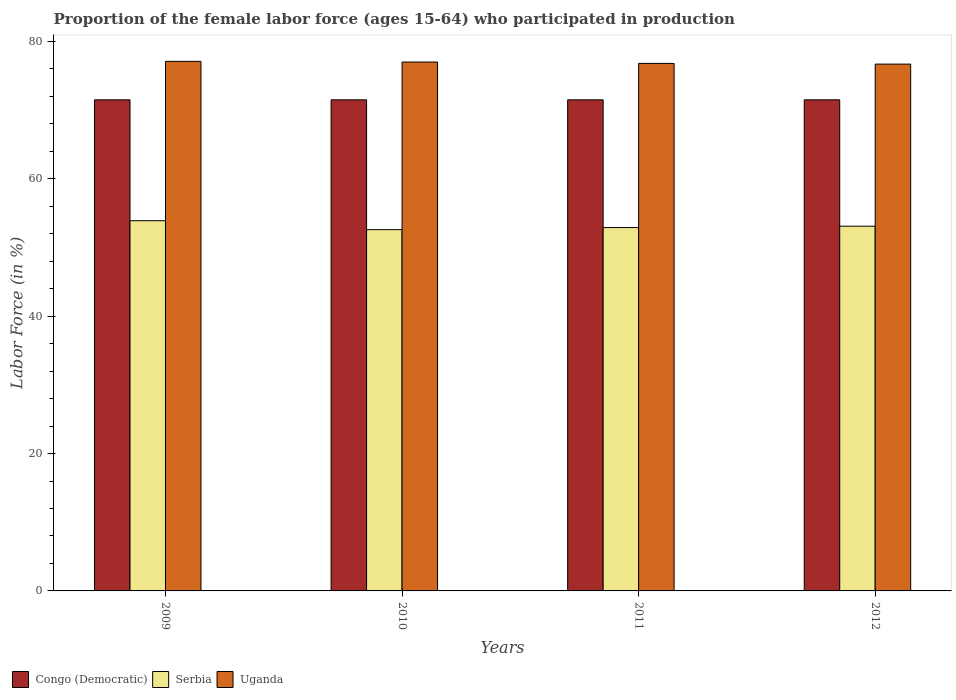How many groups of bars are there?
Provide a succinct answer. 4. Are the number of bars per tick equal to the number of legend labels?
Ensure brevity in your answer.  Yes. How many bars are there on the 2nd tick from the right?
Ensure brevity in your answer.  3. What is the label of the 2nd group of bars from the left?
Ensure brevity in your answer.  2010. Across all years, what is the maximum proportion of the female labor force who participated in production in Serbia?
Provide a short and direct response. 53.9. Across all years, what is the minimum proportion of the female labor force who participated in production in Congo (Democratic)?
Offer a terse response. 71.5. In which year was the proportion of the female labor force who participated in production in Serbia maximum?
Ensure brevity in your answer.  2009. What is the total proportion of the female labor force who participated in production in Uganda in the graph?
Provide a succinct answer. 307.6. What is the difference between the proportion of the female labor force who participated in production in Uganda in 2009 and that in 2011?
Keep it short and to the point. 0.3. What is the difference between the proportion of the female labor force who participated in production in Serbia in 2011 and the proportion of the female labor force who participated in production in Uganda in 2009?
Your answer should be very brief. -24.2. What is the average proportion of the female labor force who participated in production in Congo (Democratic) per year?
Provide a short and direct response. 71.5. In the year 2009, what is the difference between the proportion of the female labor force who participated in production in Congo (Democratic) and proportion of the female labor force who participated in production in Serbia?
Make the answer very short. 17.6. In how many years, is the proportion of the female labor force who participated in production in Congo (Democratic) greater than 68 %?
Offer a very short reply. 4. What is the ratio of the proportion of the female labor force who participated in production in Serbia in 2009 to that in 2011?
Make the answer very short. 1.02. Is the proportion of the female labor force who participated in production in Serbia in 2011 less than that in 2012?
Your response must be concise. Yes. Is the difference between the proportion of the female labor force who participated in production in Congo (Democratic) in 2009 and 2010 greater than the difference between the proportion of the female labor force who participated in production in Serbia in 2009 and 2010?
Provide a short and direct response. No. What is the difference between the highest and the second highest proportion of the female labor force who participated in production in Uganda?
Offer a terse response. 0.1. What is the difference between the highest and the lowest proportion of the female labor force who participated in production in Congo (Democratic)?
Your answer should be compact. 0. Is the sum of the proportion of the female labor force who participated in production in Congo (Democratic) in 2009 and 2010 greater than the maximum proportion of the female labor force who participated in production in Uganda across all years?
Offer a very short reply. Yes. What does the 2nd bar from the left in 2011 represents?
Ensure brevity in your answer.  Serbia. What does the 3rd bar from the right in 2012 represents?
Make the answer very short. Congo (Democratic). Is it the case that in every year, the sum of the proportion of the female labor force who participated in production in Congo (Democratic) and proportion of the female labor force who participated in production in Uganda is greater than the proportion of the female labor force who participated in production in Serbia?
Your response must be concise. Yes. Are all the bars in the graph horizontal?
Keep it short and to the point. No. What is the difference between two consecutive major ticks on the Y-axis?
Your response must be concise. 20. Are the values on the major ticks of Y-axis written in scientific E-notation?
Give a very brief answer. No. Does the graph contain grids?
Ensure brevity in your answer.  No. How are the legend labels stacked?
Give a very brief answer. Horizontal. What is the title of the graph?
Give a very brief answer. Proportion of the female labor force (ages 15-64) who participated in production. What is the label or title of the X-axis?
Ensure brevity in your answer.  Years. What is the label or title of the Y-axis?
Keep it short and to the point. Labor Force (in %). What is the Labor Force (in %) of Congo (Democratic) in 2009?
Your answer should be compact. 71.5. What is the Labor Force (in %) in Serbia in 2009?
Ensure brevity in your answer.  53.9. What is the Labor Force (in %) in Uganda in 2009?
Offer a very short reply. 77.1. What is the Labor Force (in %) of Congo (Democratic) in 2010?
Make the answer very short. 71.5. What is the Labor Force (in %) of Serbia in 2010?
Your answer should be very brief. 52.6. What is the Labor Force (in %) of Uganda in 2010?
Your response must be concise. 77. What is the Labor Force (in %) in Congo (Democratic) in 2011?
Give a very brief answer. 71.5. What is the Labor Force (in %) in Serbia in 2011?
Keep it short and to the point. 52.9. What is the Labor Force (in %) of Uganda in 2011?
Your response must be concise. 76.8. What is the Labor Force (in %) in Congo (Democratic) in 2012?
Your response must be concise. 71.5. What is the Labor Force (in %) of Serbia in 2012?
Make the answer very short. 53.1. What is the Labor Force (in %) of Uganda in 2012?
Your answer should be very brief. 76.7. Across all years, what is the maximum Labor Force (in %) of Congo (Democratic)?
Give a very brief answer. 71.5. Across all years, what is the maximum Labor Force (in %) in Serbia?
Keep it short and to the point. 53.9. Across all years, what is the maximum Labor Force (in %) in Uganda?
Your answer should be compact. 77.1. Across all years, what is the minimum Labor Force (in %) in Congo (Democratic)?
Your answer should be very brief. 71.5. Across all years, what is the minimum Labor Force (in %) of Serbia?
Make the answer very short. 52.6. Across all years, what is the minimum Labor Force (in %) of Uganda?
Provide a succinct answer. 76.7. What is the total Labor Force (in %) in Congo (Democratic) in the graph?
Make the answer very short. 286. What is the total Labor Force (in %) in Serbia in the graph?
Provide a short and direct response. 212.5. What is the total Labor Force (in %) in Uganda in the graph?
Give a very brief answer. 307.6. What is the difference between the Labor Force (in %) of Serbia in 2009 and that in 2010?
Offer a terse response. 1.3. What is the difference between the Labor Force (in %) of Serbia in 2009 and that in 2011?
Provide a short and direct response. 1. What is the difference between the Labor Force (in %) in Uganda in 2009 and that in 2011?
Ensure brevity in your answer.  0.3. What is the difference between the Labor Force (in %) of Serbia in 2009 and that in 2012?
Offer a very short reply. 0.8. What is the difference between the Labor Force (in %) in Congo (Democratic) in 2010 and that in 2012?
Your response must be concise. 0. What is the difference between the Labor Force (in %) of Serbia in 2010 and that in 2012?
Your response must be concise. -0.5. What is the difference between the Labor Force (in %) in Uganda in 2010 and that in 2012?
Offer a terse response. 0.3. What is the difference between the Labor Force (in %) of Serbia in 2011 and that in 2012?
Ensure brevity in your answer.  -0.2. What is the difference between the Labor Force (in %) of Uganda in 2011 and that in 2012?
Give a very brief answer. 0.1. What is the difference between the Labor Force (in %) in Congo (Democratic) in 2009 and the Labor Force (in %) in Serbia in 2010?
Offer a very short reply. 18.9. What is the difference between the Labor Force (in %) in Congo (Democratic) in 2009 and the Labor Force (in %) in Uganda in 2010?
Offer a terse response. -5.5. What is the difference between the Labor Force (in %) of Serbia in 2009 and the Labor Force (in %) of Uganda in 2010?
Your answer should be compact. -23.1. What is the difference between the Labor Force (in %) in Congo (Democratic) in 2009 and the Labor Force (in %) in Serbia in 2011?
Ensure brevity in your answer.  18.6. What is the difference between the Labor Force (in %) of Congo (Democratic) in 2009 and the Labor Force (in %) of Uganda in 2011?
Your answer should be compact. -5.3. What is the difference between the Labor Force (in %) in Serbia in 2009 and the Labor Force (in %) in Uganda in 2011?
Provide a short and direct response. -22.9. What is the difference between the Labor Force (in %) in Serbia in 2009 and the Labor Force (in %) in Uganda in 2012?
Your answer should be compact. -22.8. What is the difference between the Labor Force (in %) in Congo (Democratic) in 2010 and the Labor Force (in %) in Serbia in 2011?
Make the answer very short. 18.6. What is the difference between the Labor Force (in %) of Serbia in 2010 and the Labor Force (in %) of Uganda in 2011?
Provide a short and direct response. -24.2. What is the difference between the Labor Force (in %) of Serbia in 2010 and the Labor Force (in %) of Uganda in 2012?
Provide a succinct answer. -24.1. What is the difference between the Labor Force (in %) of Serbia in 2011 and the Labor Force (in %) of Uganda in 2012?
Offer a very short reply. -23.8. What is the average Labor Force (in %) in Congo (Democratic) per year?
Offer a terse response. 71.5. What is the average Labor Force (in %) in Serbia per year?
Your response must be concise. 53.12. What is the average Labor Force (in %) of Uganda per year?
Your answer should be very brief. 76.9. In the year 2009, what is the difference between the Labor Force (in %) in Congo (Democratic) and Labor Force (in %) in Uganda?
Offer a terse response. -5.6. In the year 2009, what is the difference between the Labor Force (in %) of Serbia and Labor Force (in %) of Uganda?
Provide a succinct answer. -23.2. In the year 2010, what is the difference between the Labor Force (in %) in Congo (Democratic) and Labor Force (in %) in Serbia?
Offer a terse response. 18.9. In the year 2010, what is the difference between the Labor Force (in %) in Serbia and Labor Force (in %) in Uganda?
Provide a short and direct response. -24.4. In the year 2011, what is the difference between the Labor Force (in %) in Congo (Democratic) and Labor Force (in %) in Uganda?
Provide a succinct answer. -5.3. In the year 2011, what is the difference between the Labor Force (in %) in Serbia and Labor Force (in %) in Uganda?
Provide a short and direct response. -23.9. In the year 2012, what is the difference between the Labor Force (in %) of Serbia and Labor Force (in %) of Uganda?
Provide a short and direct response. -23.6. What is the ratio of the Labor Force (in %) of Serbia in 2009 to that in 2010?
Your answer should be very brief. 1.02. What is the ratio of the Labor Force (in %) in Congo (Democratic) in 2009 to that in 2011?
Your answer should be compact. 1. What is the ratio of the Labor Force (in %) of Serbia in 2009 to that in 2011?
Provide a short and direct response. 1.02. What is the ratio of the Labor Force (in %) in Serbia in 2009 to that in 2012?
Keep it short and to the point. 1.02. What is the ratio of the Labor Force (in %) in Uganda in 2009 to that in 2012?
Provide a short and direct response. 1.01. What is the ratio of the Labor Force (in %) of Serbia in 2010 to that in 2011?
Your response must be concise. 0.99. What is the ratio of the Labor Force (in %) in Uganda in 2010 to that in 2011?
Provide a succinct answer. 1. What is the ratio of the Labor Force (in %) in Serbia in 2010 to that in 2012?
Offer a very short reply. 0.99. What is the ratio of the Labor Force (in %) of Congo (Democratic) in 2011 to that in 2012?
Offer a terse response. 1. What is the ratio of the Labor Force (in %) in Serbia in 2011 to that in 2012?
Provide a succinct answer. 1. What is the difference between the highest and the second highest Labor Force (in %) in Congo (Democratic)?
Your response must be concise. 0. What is the difference between the highest and the second highest Labor Force (in %) of Serbia?
Your answer should be compact. 0.8. 